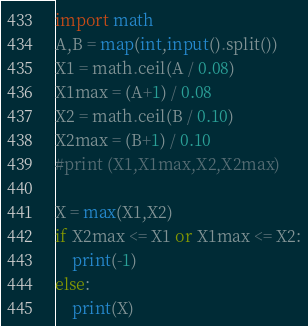<code> <loc_0><loc_0><loc_500><loc_500><_Python_>import math
A,B = map(int,input().split())
X1 = math.ceil(A / 0.08)
X1max = (A+1) / 0.08
X2 = math.ceil(B / 0.10)
X2max = (B+1) / 0.10
#print (X1,X1max,X2,X2max)

X = max(X1,X2)
if X2max <= X1 or X1max <= X2:
    print(-1)
else:
    print(X)</code> 